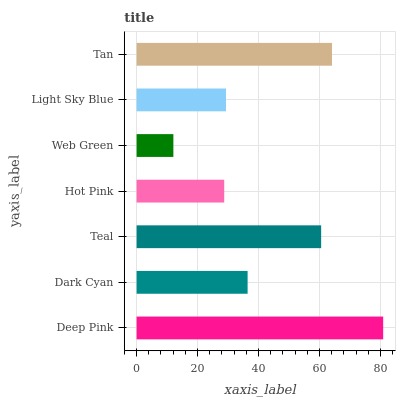Is Web Green the minimum?
Answer yes or no. Yes. Is Deep Pink the maximum?
Answer yes or no. Yes. Is Dark Cyan the minimum?
Answer yes or no. No. Is Dark Cyan the maximum?
Answer yes or no. No. Is Deep Pink greater than Dark Cyan?
Answer yes or no. Yes. Is Dark Cyan less than Deep Pink?
Answer yes or no. Yes. Is Dark Cyan greater than Deep Pink?
Answer yes or no. No. Is Deep Pink less than Dark Cyan?
Answer yes or no. No. Is Dark Cyan the high median?
Answer yes or no. Yes. Is Dark Cyan the low median?
Answer yes or no. Yes. Is Deep Pink the high median?
Answer yes or no. No. Is Tan the low median?
Answer yes or no. No. 